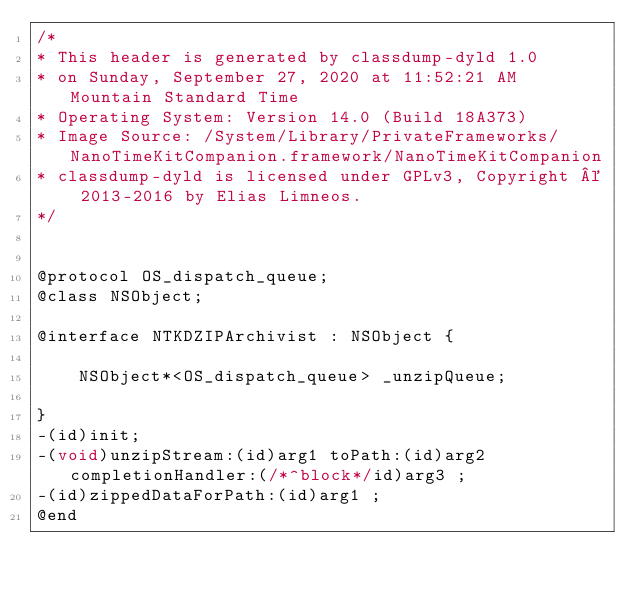Convert code to text. <code><loc_0><loc_0><loc_500><loc_500><_C_>/*
* This header is generated by classdump-dyld 1.0
* on Sunday, September 27, 2020 at 11:52:21 AM Mountain Standard Time
* Operating System: Version 14.0 (Build 18A373)
* Image Source: /System/Library/PrivateFrameworks/NanoTimeKitCompanion.framework/NanoTimeKitCompanion
* classdump-dyld is licensed under GPLv3, Copyright © 2013-2016 by Elias Limneos.
*/


@protocol OS_dispatch_queue;
@class NSObject;

@interface NTKDZIPArchivist : NSObject {

	NSObject*<OS_dispatch_queue> _unzipQueue;

}
-(id)init;
-(void)unzipStream:(id)arg1 toPath:(id)arg2 completionHandler:(/*^block*/id)arg3 ;
-(id)zippedDataForPath:(id)arg1 ;
@end

</code> 